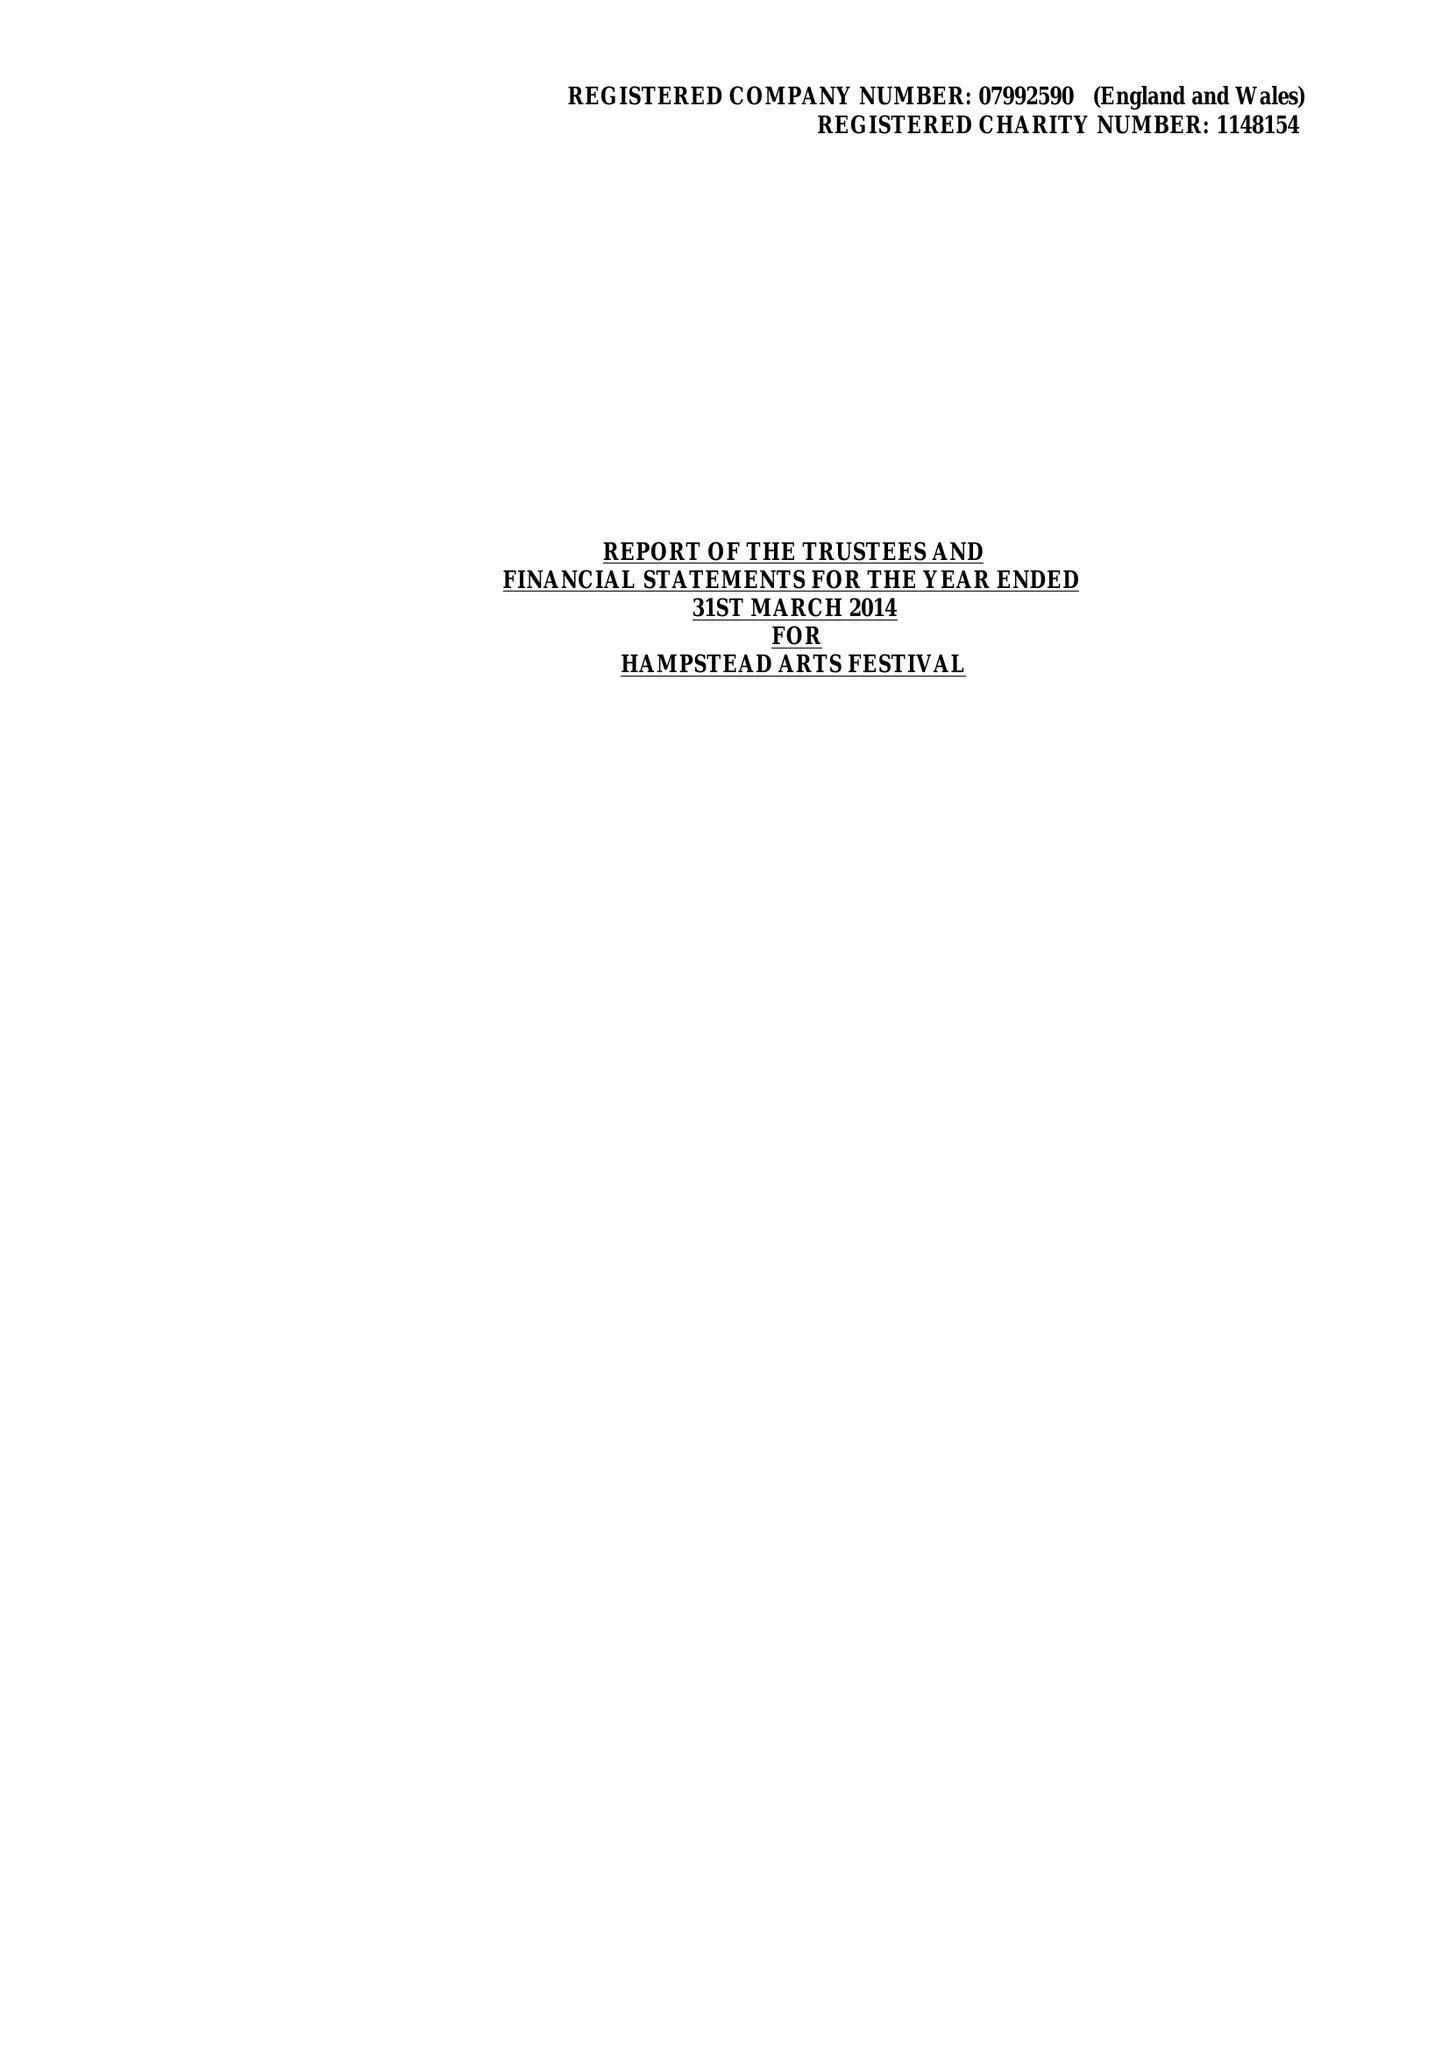What is the value for the report_date?
Answer the question using a single word or phrase. 2014-03-31 